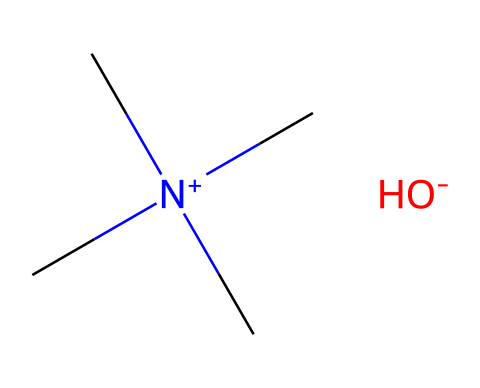What is the molecular formula of tetramethylammonium hydroxide? From the SMILES representation, the components can be identified: 'N' indicates nitrogen, 'C' indicates carbon, and 'OH' refers to a hydroxide group. Counting the atoms, we have 1 nitrogen, 4 carbons from the four methyl groups, and 1 oxygen with hydrogen from hydroxide, leading to the formula C4H12N1O1.
Answer: C4H12NO How many methyl groups are present in tetramethylammonium hydroxide? The SMILES representation shows 'N+' bonded to four 'C's (methyl groups). Each 'C' in the representation indicates a methyl group attached to nitrogen. Therefore, the count of 'C' atoms shows that there are four methyl groups.
Answer: 4 What charge does the nitrogen carry in the molecular structure? The 'N+' notation in the SMILES indicates that nitrogen carries a positive charge. No other specifications in the structure indicate any other charge state for nitrogen. Thus, the charge of nitrogen is +1.
Answer: +1 What type of base is tetramethylammonium hydroxide? Tetramethylammonium hydroxide is classified as a strong organic base, indicated by the presence of the hydroxide ion (OH-) and its structure as a quaternary ammonium compound.
Answer: strong organic base What is the role of the hydroxide ion in tetramethylammonium hydroxide? The hydroxide ion (OH-) contributes to the basicity of the compound, allowing it to accept protons and increase the pH of a solution. It is a strong base that, together with the quaternary ammonium structure, enhances proton acceptance.
Answer: increases basicity How does the presence of the quaternary ammonium structure affect the solubility of this compound? Quaternary ammonium compounds, such as tetramethylammonium hydroxide, have high solubility in polar solvents due to their charge and structural properties. The charged nitrogen facilitates interaction with solvent molecules, enhancing solubility.
Answer: high solubility 